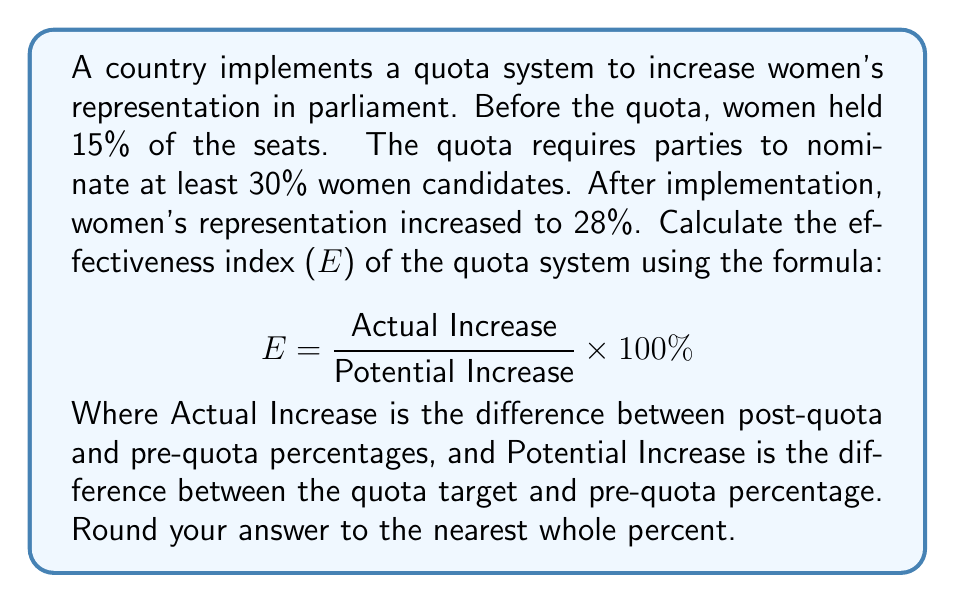Could you help me with this problem? To calculate the effectiveness index (E) of the quota system, we need to follow these steps:

1. Calculate the Actual Increase:
   $\text{Actual Increase} = \text{Post-quota percentage} - \text{Pre-quota percentage}$
   $\text{Actual Increase} = 28\% - 15\% = 13\%$

2. Calculate the Potential Increase:
   $\text{Potential Increase} = \text{Quota target} - \text{Pre-quota percentage}$
   $\text{Potential Increase} = 30\% - 15\% = 15\%$

3. Apply the formula for the effectiveness index:
   $$ E = \frac{\text{Actual Increase}}{\text{Potential Increase}} \times 100\% $$
   
   $$ E = \frac{13\%}{15\%} \times 100\% $$
   
   $$ E = 0.8666... \times 100\% = 86.66...\% $$

4. Round the result to the nearest whole percent:
   $86.66...\% \approx 87\%$

The effectiveness index of 87% indicates that the quota system was highly effective in increasing women's representation, achieving 87% of its potential increase.
Answer: 87% 